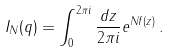Convert formula to latex. <formula><loc_0><loc_0><loc_500><loc_500>I _ { N } ( q ) = \int _ { 0 } ^ { 2 \pi i } \frac { d z } { 2 \pi i } e ^ { N f ( z ) } \, .</formula> 